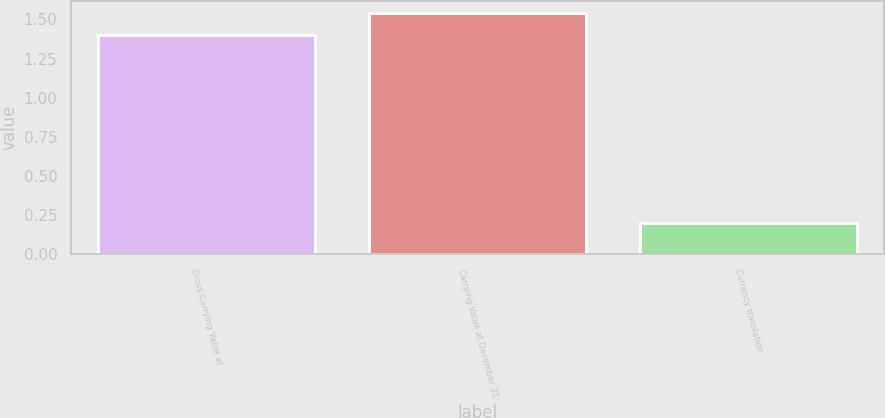Convert chart. <chart><loc_0><loc_0><loc_500><loc_500><bar_chart><fcel>Gross Carrying Value at<fcel>Carrying Value at December 31<fcel>Currency translation<nl><fcel>1.4<fcel>1.54<fcel>0.2<nl></chart> 